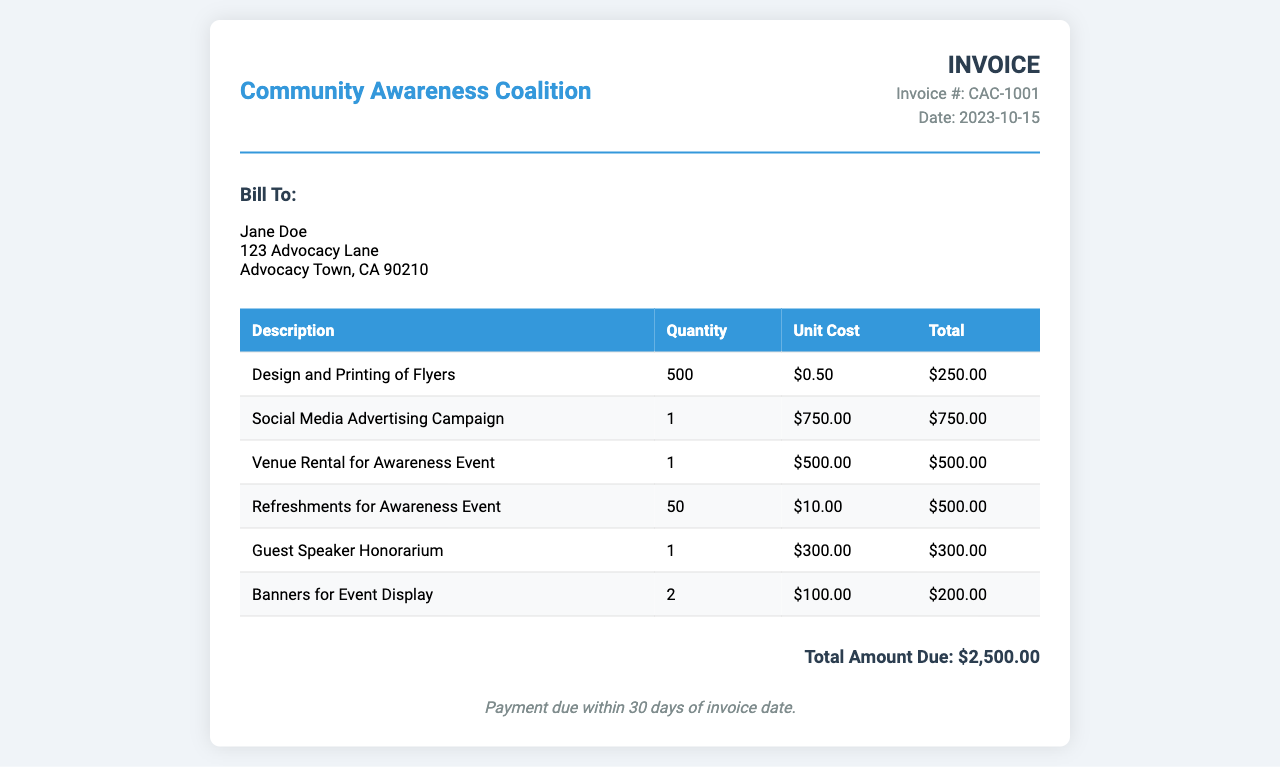What is the invoice number? The invoice number is listed in the invoice details section, which is CAC-1001.
Answer: CAC-1001 Who is the invoice billed to? The billing information section specifies the name of the person to whom the invoice is billed, which is Jane Doe.
Answer: Jane Doe What is the total amount due? The total amount due is stated at the bottom of the invoice, which sums up all the itemized expenses, totaling $2,500.00.
Answer: $2,500.00 How many flyers were designed and printed? The invoice lists 500 as the quantity of flyers designed and printed.
Answer: 500 What was the unit cost for refreshments? The unit cost for refreshments for the awareness event is mentioned as $10.00.
Answer: $10.00 What is the date of the invoice? The date is part of the invoice details section, indicating it was issued on 2023-10-15.
Answer: 2023-10-15 What is the quantity of guest speaker honorarium? The invoice specifies a quantity of 1 for the guest speaker honorarium.
Answer: 1 What was the total amount billed for social media advertising? The total cost for the social media advertising campaign, as per the invoice, is $750.00.
Answer: $750.00 What are the payment terms? The payment terms are outlined at the bottom of the invoice, stating that payment is due within 30 days of the invoice date.
Answer: Payment due within 30 days of invoice date 